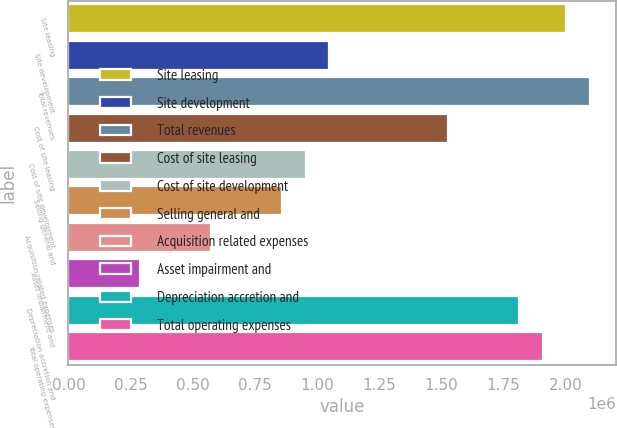<chart> <loc_0><loc_0><loc_500><loc_500><bar_chart><fcel>Site leasing<fcel>Site development<fcel>Total revenues<fcel>Cost of site leasing<fcel>Cost of site development<fcel>Selling general and<fcel>Acquisition related expenses<fcel>Asset impairment and<fcel>Depreciation accretion and<fcel>Total operating expenses<nl><fcel>2.00319e+06<fcel>1.04946e+06<fcel>2.09856e+06<fcel>1.52632e+06<fcel>954084<fcel>858711<fcel>572592<fcel>286472<fcel>1.81244e+06<fcel>1.90782e+06<nl></chart> 